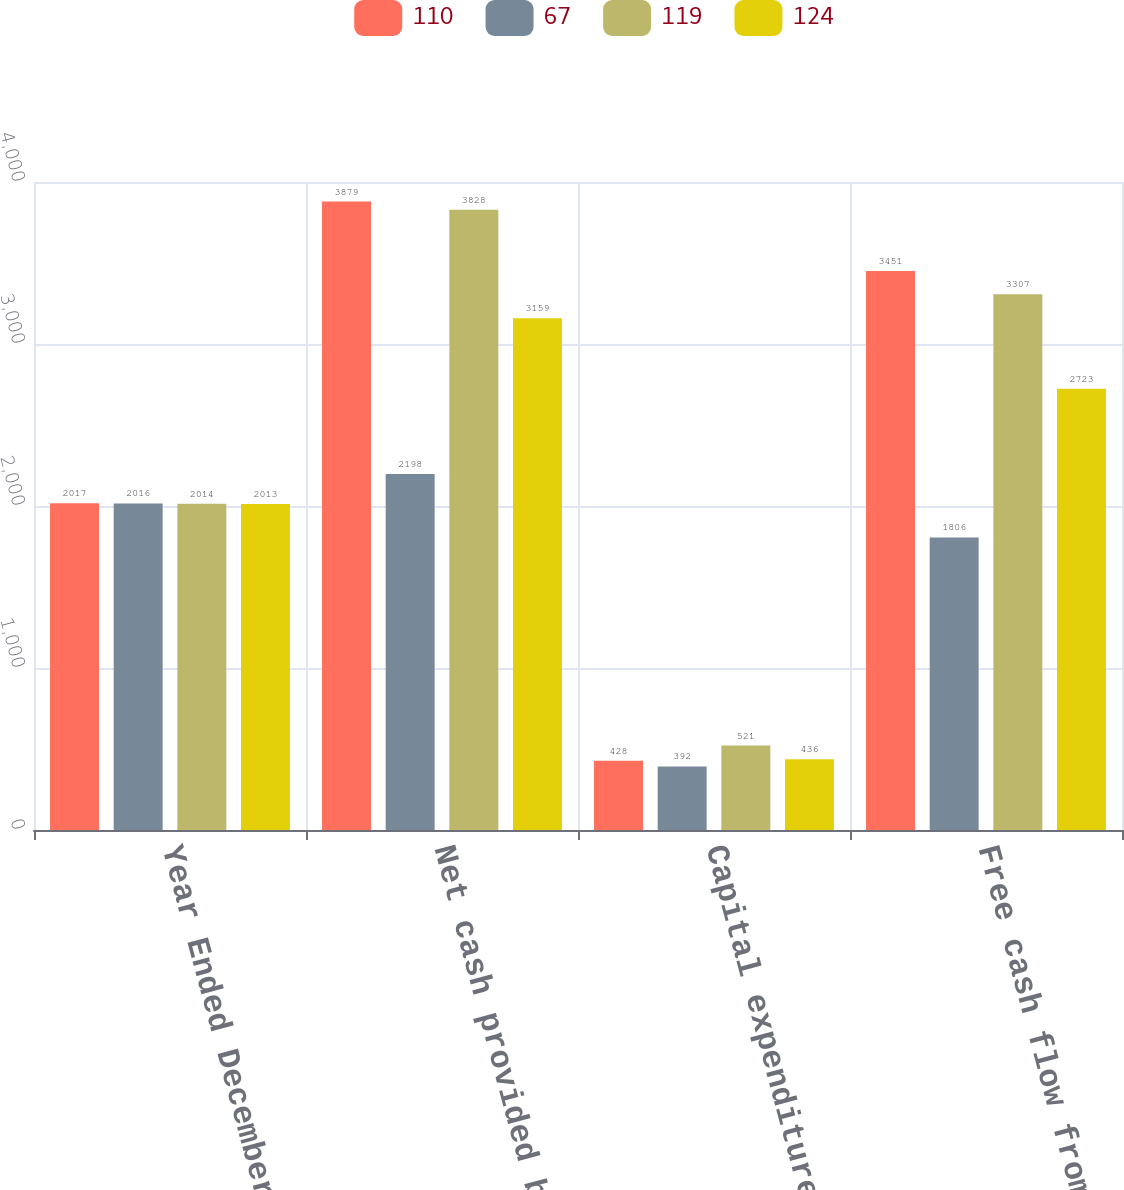<chart> <loc_0><loc_0><loc_500><loc_500><stacked_bar_chart><ecel><fcel>Year Ended December 31<fcel>Net cash provided by operating<fcel>Capital expenditures<fcel>Free cash flow from operations<nl><fcel>110<fcel>2017<fcel>3879<fcel>428<fcel>3451<nl><fcel>67<fcel>2016<fcel>2198<fcel>392<fcel>1806<nl><fcel>119<fcel>2014<fcel>3828<fcel>521<fcel>3307<nl><fcel>124<fcel>2013<fcel>3159<fcel>436<fcel>2723<nl></chart> 